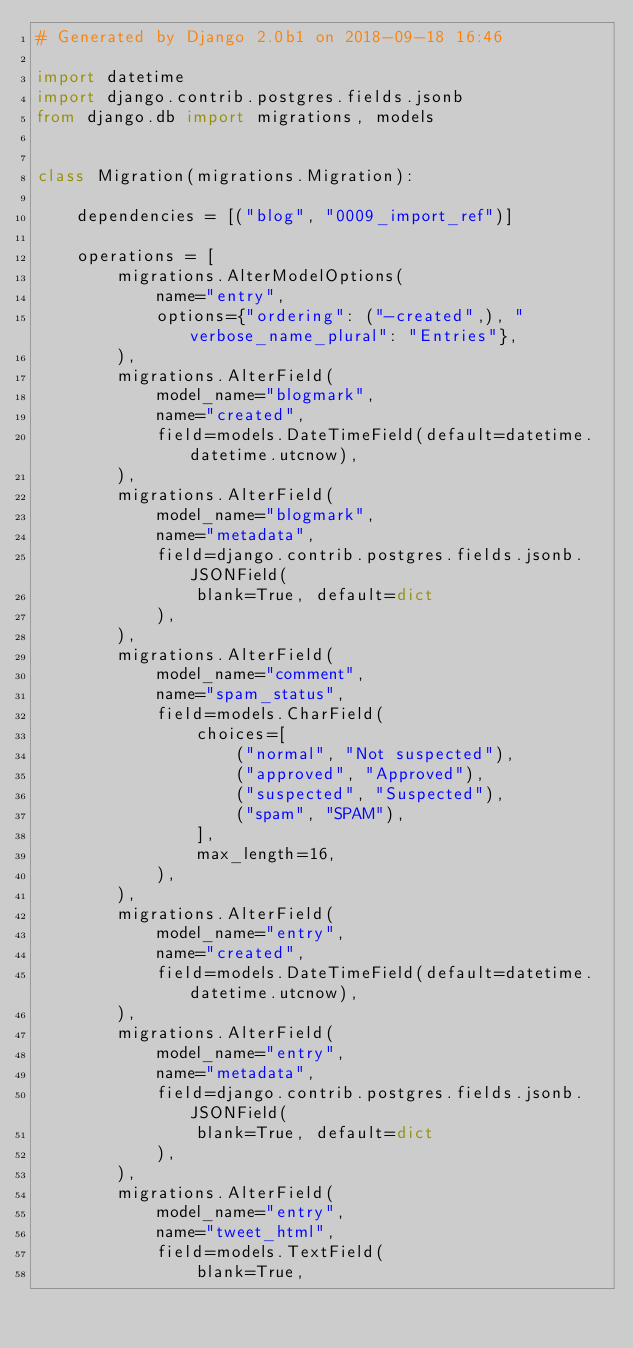<code> <loc_0><loc_0><loc_500><loc_500><_Python_># Generated by Django 2.0b1 on 2018-09-18 16:46

import datetime
import django.contrib.postgres.fields.jsonb
from django.db import migrations, models


class Migration(migrations.Migration):

    dependencies = [("blog", "0009_import_ref")]

    operations = [
        migrations.AlterModelOptions(
            name="entry",
            options={"ordering": ("-created",), "verbose_name_plural": "Entries"},
        ),
        migrations.AlterField(
            model_name="blogmark",
            name="created",
            field=models.DateTimeField(default=datetime.datetime.utcnow),
        ),
        migrations.AlterField(
            model_name="blogmark",
            name="metadata",
            field=django.contrib.postgres.fields.jsonb.JSONField(
                blank=True, default=dict
            ),
        ),
        migrations.AlterField(
            model_name="comment",
            name="spam_status",
            field=models.CharField(
                choices=[
                    ("normal", "Not suspected"),
                    ("approved", "Approved"),
                    ("suspected", "Suspected"),
                    ("spam", "SPAM"),
                ],
                max_length=16,
            ),
        ),
        migrations.AlterField(
            model_name="entry",
            name="created",
            field=models.DateTimeField(default=datetime.datetime.utcnow),
        ),
        migrations.AlterField(
            model_name="entry",
            name="metadata",
            field=django.contrib.postgres.fields.jsonb.JSONField(
                blank=True, default=dict
            ),
        ),
        migrations.AlterField(
            model_name="entry",
            name="tweet_html",
            field=models.TextField(
                blank=True,</code> 